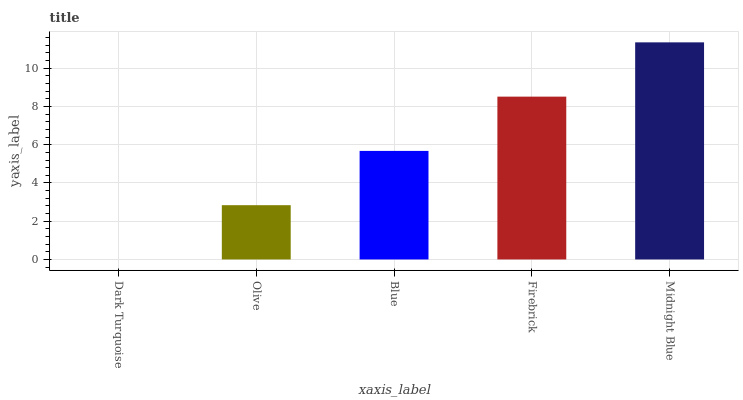Is Dark Turquoise the minimum?
Answer yes or no. Yes. Is Midnight Blue the maximum?
Answer yes or no. Yes. Is Olive the minimum?
Answer yes or no. No. Is Olive the maximum?
Answer yes or no. No. Is Olive greater than Dark Turquoise?
Answer yes or no. Yes. Is Dark Turquoise less than Olive?
Answer yes or no. Yes. Is Dark Turquoise greater than Olive?
Answer yes or no. No. Is Olive less than Dark Turquoise?
Answer yes or no. No. Is Blue the high median?
Answer yes or no. Yes. Is Blue the low median?
Answer yes or no. Yes. Is Midnight Blue the high median?
Answer yes or no. No. Is Dark Turquoise the low median?
Answer yes or no. No. 